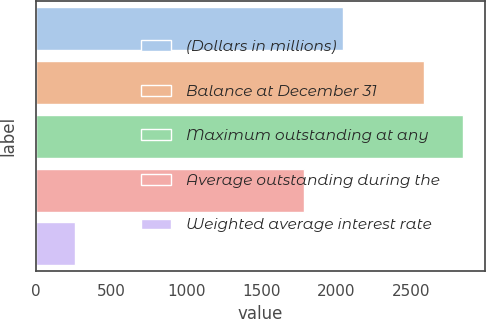Convert chart. <chart><loc_0><loc_0><loc_500><loc_500><bar_chart><fcel>(Dollars in millions)<fcel>Balance at December 31<fcel>Maximum outstanding at any<fcel>Average outstanding during the<fcel>Weighted average interest rate<nl><fcel>2042.72<fcel>2588<fcel>2846.72<fcel>1784<fcel>259.54<nl></chart> 